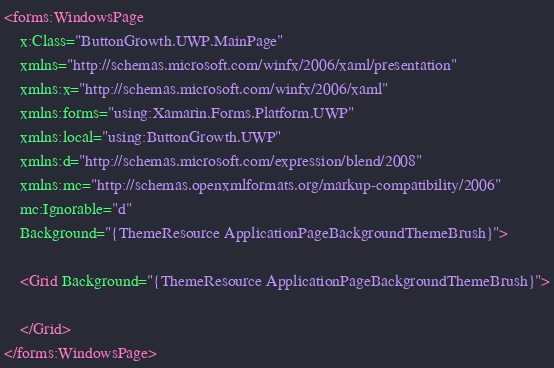<code> <loc_0><loc_0><loc_500><loc_500><_XML_><forms:WindowsPage
    x:Class="ButtonGrowth.UWP.MainPage"
    xmlns="http://schemas.microsoft.com/winfx/2006/xaml/presentation"
    xmlns:x="http://schemas.microsoft.com/winfx/2006/xaml"
    xmlns:forms="using:Xamarin.Forms.Platform.UWP"
    xmlns:local="using:ButtonGrowth.UWP"
    xmlns:d="http://schemas.microsoft.com/expression/blend/2008"
    xmlns:mc="http://schemas.openxmlformats.org/markup-compatibility/2006"
    mc:Ignorable="d"
    Background="{ThemeResource ApplicationPageBackgroundThemeBrush}">

    <Grid Background="{ThemeResource ApplicationPageBackgroundThemeBrush}">

    </Grid>
</forms:WindowsPage>
</code> 